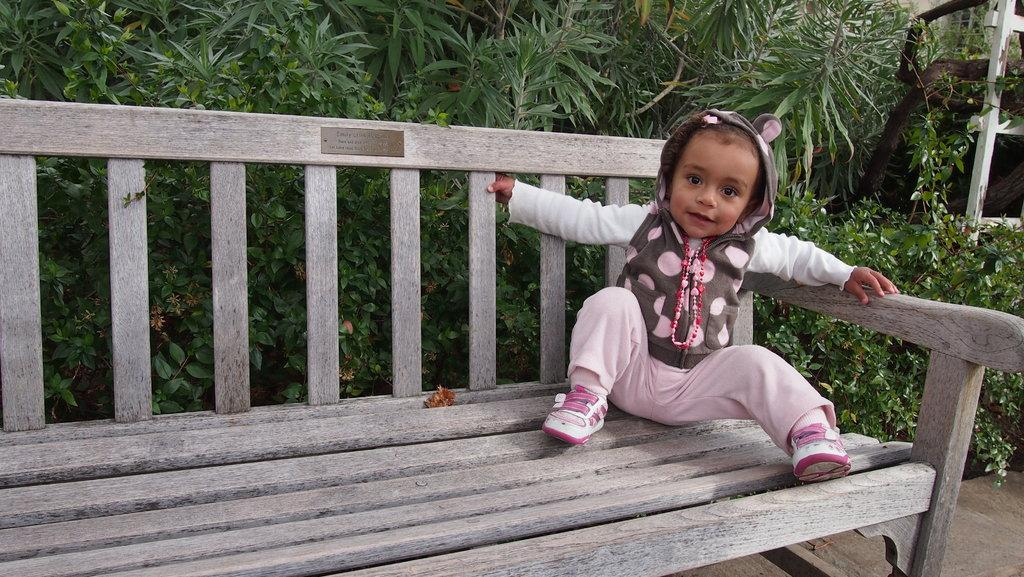What is the main subject of the picture? The main subject of the picture is a baby. Where is the baby sitting in the picture? The baby is sitting on a bench. What material is the bench made of? The bench is made of wood. What can be seen in the background of the picture? There are plants and a stand in the background of the picture. What type of pear is the baby holding in the picture? There is no pear present in the image; the baby is sitting on a bench. Can you tell me how many cats are visible in the picture? There are no cats present in the image; the main subject is a baby sitting on a bench. 